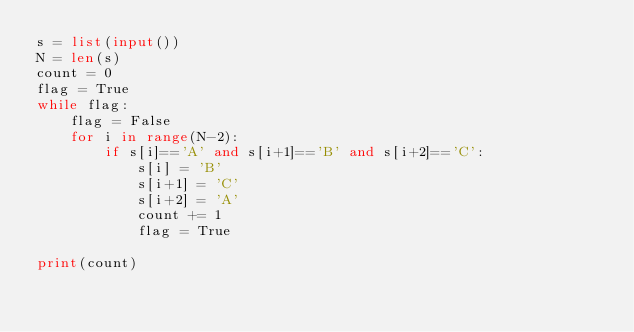Convert code to text. <code><loc_0><loc_0><loc_500><loc_500><_Python_>s = list(input())
N = len(s)
count = 0
flag = True
while flag:
    flag = False
    for i in range(N-2):
        if s[i]=='A' and s[i+1]=='B' and s[i+2]=='C':
            s[i] = 'B'
            s[i+1] = 'C'
            s[i+2] = 'A'
            count += 1
            flag = True

print(count)</code> 